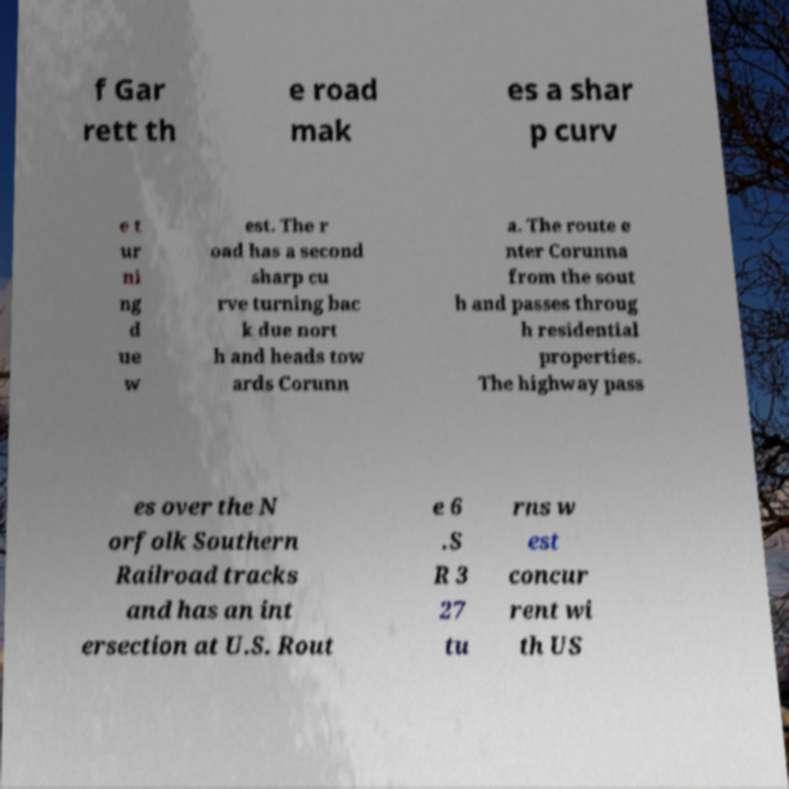Could you assist in decoding the text presented in this image and type it out clearly? f Gar rett th e road mak es a shar p curv e t ur ni ng d ue w est. The r oad has a second sharp cu rve turning bac k due nort h and heads tow ards Corunn a. The route e nter Corunna from the sout h and passes throug h residential properties. The highway pass es over the N orfolk Southern Railroad tracks and has an int ersection at U.S. Rout e 6 .S R 3 27 tu rns w est concur rent wi th US 